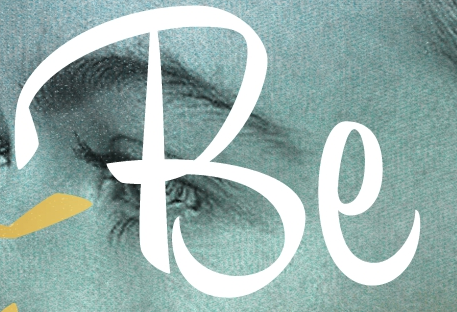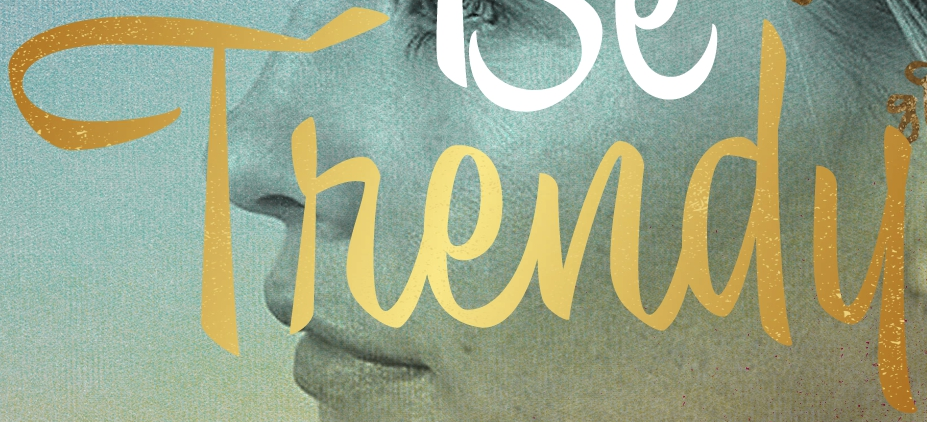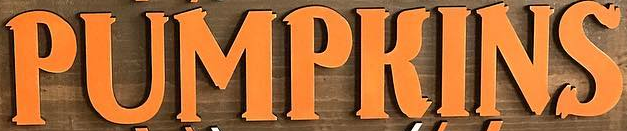Transcribe the words shown in these images in order, separated by a semicolon. Be; Thendu; PUMPKINS 